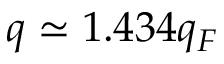<formula> <loc_0><loc_0><loc_500><loc_500>q \simeq 1 . 4 3 4 q _ { F }</formula> 